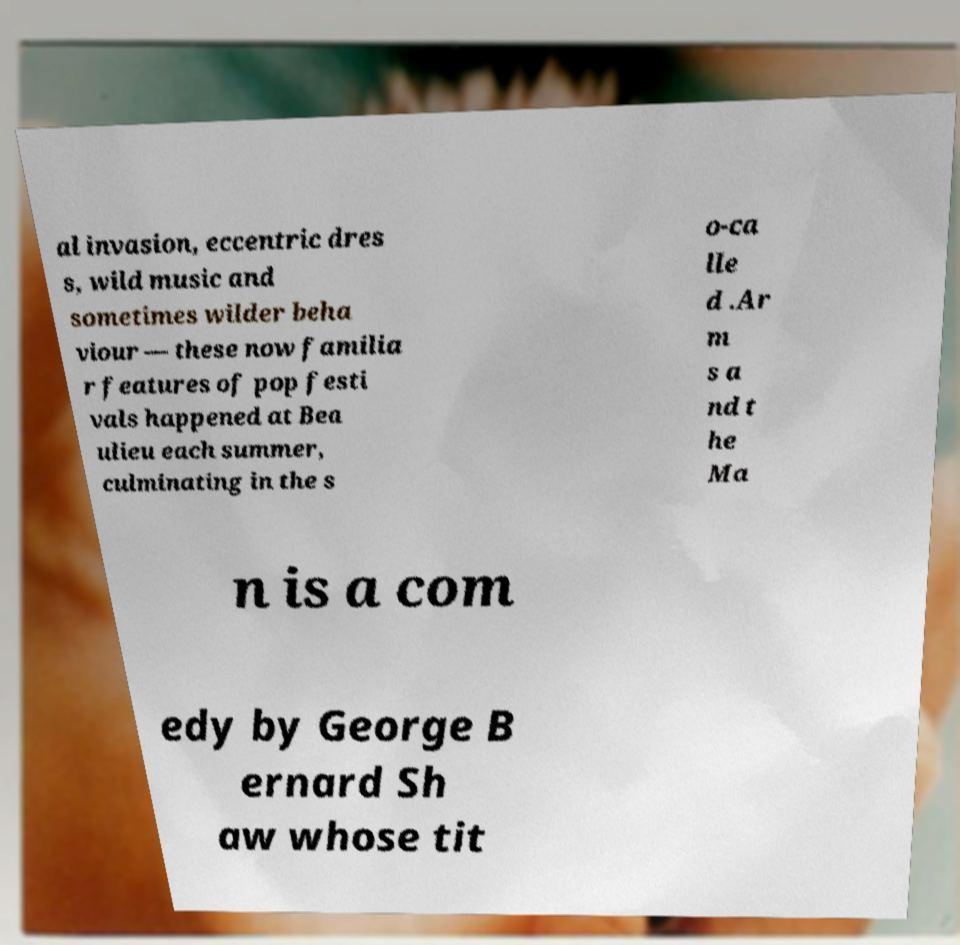There's text embedded in this image that I need extracted. Can you transcribe it verbatim? al invasion, eccentric dres s, wild music and sometimes wilder beha viour — these now familia r features of pop festi vals happened at Bea ulieu each summer, culminating in the s o-ca lle d .Ar m s a nd t he Ma n is a com edy by George B ernard Sh aw whose tit 